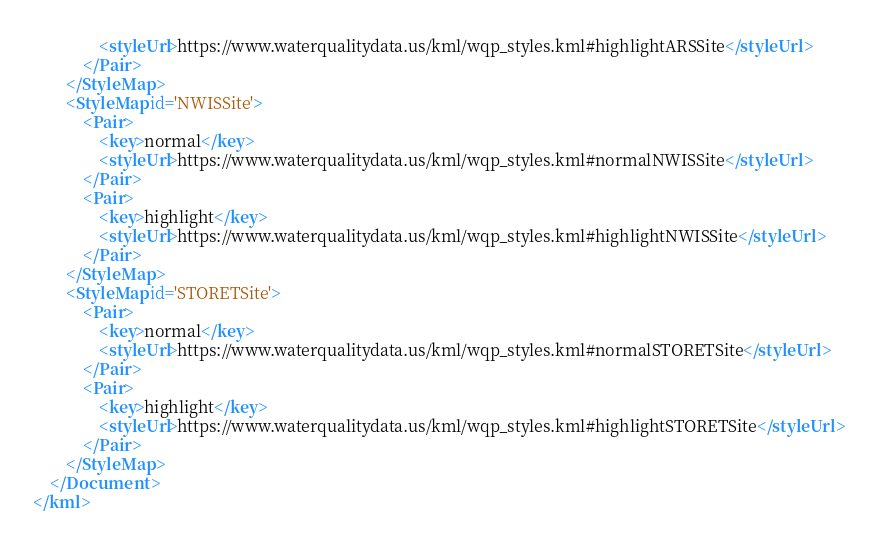<code> <loc_0><loc_0><loc_500><loc_500><_XML_>				<styleUrl>https://www.waterqualitydata.us/kml/wqp_styles.kml#highlightARSSite</styleUrl>
			</Pair>
		</StyleMap>
		<StyleMap id='NWISSite'>
			<Pair>
				<key>normal</key>
				<styleUrl>https://www.waterqualitydata.us/kml/wqp_styles.kml#normalNWISSite</styleUrl>
			</Pair>
			<Pair>
				<key>highlight</key>
				<styleUrl>https://www.waterqualitydata.us/kml/wqp_styles.kml#highlightNWISSite</styleUrl>
			</Pair>
		</StyleMap>
		<StyleMap id='STORETSite'>
			<Pair>
				<key>normal</key>
				<styleUrl>https://www.waterqualitydata.us/kml/wqp_styles.kml#normalSTORETSite</styleUrl>
			</Pair>
			<Pair>
				<key>highlight</key>
				<styleUrl>https://www.waterqualitydata.us/kml/wqp_styles.kml#highlightSTORETSite</styleUrl>
			</Pair>
		</StyleMap>
	</Document>
</kml></code> 